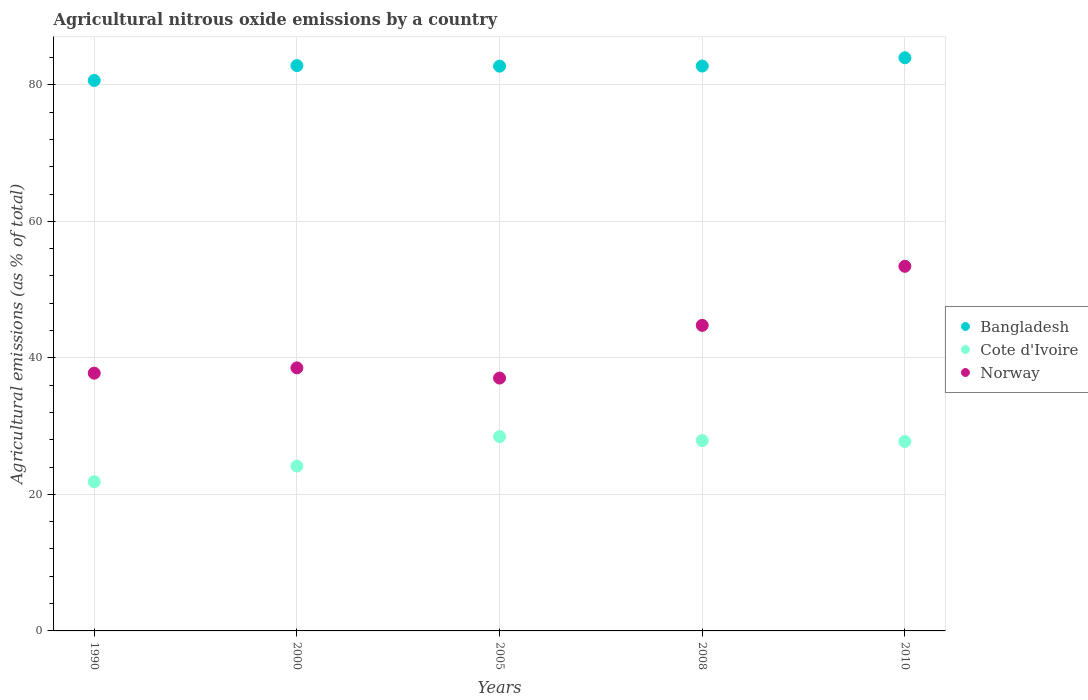How many different coloured dotlines are there?
Make the answer very short. 3. What is the amount of agricultural nitrous oxide emitted in Norway in 2005?
Offer a terse response. 37.04. Across all years, what is the maximum amount of agricultural nitrous oxide emitted in Cote d'Ivoire?
Your answer should be very brief. 28.46. Across all years, what is the minimum amount of agricultural nitrous oxide emitted in Cote d'Ivoire?
Offer a very short reply. 21.85. What is the total amount of agricultural nitrous oxide emitted in Cote d'Ivoire in the graph?
Ensure brevity in your answer.  130.09. What is the difference between the amount of agricultural nitrous oxide emitted in Cote d'Ivoire in 2005 and that in 2008?
Your answer should be compact. 0.58. What is the difference between the amount of agricultural nitrous oxide emitted in Bangladesh in 2000 and the amount of agricultural nitrous oxide emitted in Cote d'Ivoire in 1990?
Keep it short and to the point. 60.95. What is the average amount of agricultural nitrous oxide emitted in Norway per year?
Your response must be concise. 42.3. In the year 1990, what is the difference between the amount of agricultural nitrous oxide emitted in Norway and amount of agricultural nitrous oxide emitted in Cote d'Ivoire?
Your answer should be very brief. 15.9. In how many years, is the amount of agricultural nitrous oxide emitted in Bangladesh greater than 56 %?
Give a very brief answer. 5. What is the ratio of the amount of agricultural nitrous oxide emitted in Bangladesh in 2005 to that in 2010?
Provide a succinct answer. 0.99. Is the amount of agricultural nitrous oxide emitted in Norway in 2000 less than that in 2005?
Offer a very short reply. No. What is the difference between the highest and the second highest amount of agricultural nitrous oxide emitted in Cote d'Ivoire?
Offer a very short reply. 0.58. What is the difference between the highest and the lowest amount of agricultural nitrous oxide emitted in Cote d'Ivoire?
Provide a short and direct response. 6.61. In how many years, is the amount of agricultural nitrous oxide emitted in Cote d'Ivoire greater than the average amount of agricultural nitrous oxide emitted in Cote d'Ivoire taken over all years?
Your response must be concise. 3. Is it the case that in every year, the sum of the amount of agricultural nitrous oxide emitted in Bangladesh and amount of agricultural nitrous oxide emitted in Cote d'Ivoire  is greater than the amount of agricultural nitrous oxide emitted in Norway?
Make the answer very short. Yes. Does the amount of agricultural nitrous oxide emitted in Bangladesh monotonically increase over the years?
Provide a short and direct response. No. Is the amount of agricultural nitrous oxide emitted in Cote d'Ivoire strictly greater than the amount of agricultural nitrous oxide emitted in Norway over the years?
Offer a very short reply. No. How many years are there in the graph?
Offer a very short reply. 5. Are the values on the major ticks of Y-axis written in scientific E-notation?
Offer a terse response. No. Does the graph contain any zero values?
Provide a succinct answer. No. How are the legend labels stacked?
Offer a terse response. Vertical. What is the title of the graph?
Make the answer very short. Agricultural nitrous oxide emissions by a country. What is the label or title of the X-axis?
Ensure brevity in your answer.  Years. What is the label or title of the Y-axis?
Keep it short and to the point. Agricultural emissions (as % of total). What is the Agricultural emissions (as % of total) of Bangladesh in 1990?
Ensure brevity in your answer.  80.63. What is the Agricultural emissions (as % of total) of Cote d'Ivoire in 1990?
Make the answer very short. 21.85. What is the Agricultural emissions (as % of total) of Norway in 1990?
Your answer should be very brief. 37.76. What is the Agricultural emissions (as % of total) in Bangladesh in 2000?
Offer a terse response. 82.81. What is the Agricultural emissions (as % of total) of Cote d'Ivoire in 2000?
Your answer should be compact. 24.15. What is the Agricultural emissions (as % of total) of Norway in 2000?
Give a very brief answer. 38.53. What is the Agricultural emissions (as % of total) of Bangladesh in 2005?
Your answer should be very brief. 82.73. What is the Agricultural emissions (as % of total) of Cote d'Ivoire in 2005?
Your answer should be compact. 28.46. What is the Agricultural emissions (as % of total) of Norway in 2005?
Provide a short and direct response. 37.04. What is the Agricultural emissions (as % of total) of Bangladesh in 2008?
Make the answer very short. 82.75. What is the Agricultural emissions (as % of total) of Cote d'Ivoire in 2008?
Provide a short and direct response. 27.88. What is the Agricultural emissions (as % of total) in Norway in 2008?
Ensure brevity in your answer.  44.76. What is the Agricultural emissions (as % of total) in Bangladesh in 2010?
Offer a terse response. 83.96. What is the Agricultural emissions (as % of total) of Cote d'Ivoire in 2010?
Offer a very short reply. 27.74. What is the Agricultural emissions (as % of total) in Norway in 2010?
Give a very brief answer. 53.41. Across all years, what is the maximum Agricultural emissions (as % of total) of Bangladesh?
Your response must be concise. 83.96. Across all years, what is the maximum Agricultural emissions (as % of total) of Cote d'Ivoire?
Ensure brevity in your answer.  28.46. Across all years, what is the maximum Agricultural emissions (as % of total) in Norway?
Your answer should be compact. 53.41. Across all years, what is the minimum Agricultural emissions (as % of total) in Bangladesh?
Your answer should be very brief. 80.63. Across all years, what is the minimum Agricultural emissions (as % of total) of Cote d'Ivoire?
Provide a short and direct response. 21.85. Across all years, what is the minimum Agricultural emissions (as % of total) of Norway?
Ensure brevity in your answer.  37.04. What is the total Agricultural emissions (as % of total) of Bangladesh in the graph?
Your answer should be very brief. 412.87. What is the total Agricultural emissions (as % of total) of Cote d'Ivoire in the graph?
Provide a succinct answer. 130.09. What is the total Agricultural emissions (as % of total) in Norway in the graph?
Offer a very short reply. 211.49. What is the difference between the Agricultural emissions (as % of total) in Bangladesh in 1990 and that in 2000?
Provide a succinct answer. -2.18. What is the difference between the Agricultural emissions (as % of total) of Cote d'Ivoire in 1990 and that in 2000?
Give a very brief answer. -2.29. What is the difference between the Agricultural emissions (as % of total) of Norway in 1990 and that in 2000?
Offer a very short reply. -0.78. What is the difference between the Agricultural emissions (as % of total) of Bangladesh in 1990 and that in 2005?
Ensure brevity in your answer.  -2.1. What is the difference between the Agricultural emissions (as % of total) of Cote d'Ivoire in 1990 and that in 2005?
Ensure brevity in your answer.  -6.61. What is the difference between the Agricultural emissions (as % of total) in Norway in 1990 and that in 2005?
Keep it short and to the point. 0.72. What is the difference between the Agricultural emissions (as % of total) in Bangladesh in 1990 and that in 2008?
Make the answer very short. -2.11. What is the difference between the Agricultural emissions (as % of total) of Cote d'Ivoire in 1990 and that in 2008?
Offer a terse response. -6.03. What is the difference between the Agricultural emissions (as % of total) of Norway in 1990 and that in 2008?
Make the answer very short. -7. What is the difference between the Agricultural emissions (as % of total) in Bangladesh in 1990 and that in 2010?
Offer a terse response. -3.32. What is the difference between the Agricultural emissions (as % of total) of Cote d'Ivoire in 1990 and that in 2010?
Make the answer very short. -5.89. What is the difference between the Agricultural emissions (as % of total) of Norway in 1990 and that in 2010?
Keep it short and to the point. -15.65. What is the difference between the Agricultural emissions (as % of total) of Bangladesh in 2000 and that in 2005?
Make the answer very short. 0.08. What is the difference between the Agricultural emissions (as % of total) of Cote d'Ivoire in 2000 and that in 2005?
Make the answer very short. -4.31. What is the difference between the Agricultural emissions (as % of total) in Norway in 2000 and that in 2005?
Provide a short and direct response. 1.49. What is the difference between the Agricultural emissions (as % of total) of Bangladesh in 2000 and that in 2008?
Ensure brevity in your answer.  0.06. What is the difference between the Agricultural emissions (as % of total) in Cote d'Ivoire in 2000 and that in 2008?
Make the answer very short. -3.73. What is the difference between the Agricultural emissions (as % of total) of Norway in 2000 and that in 2008?
Your answer should be compact. -6.23. What is the difference between the Agricultural emissions (as % of total) of Bangladesh in 2000 and that in 2010?
Your answer should be compact. -1.15. What is the difference between the Agricultural emissions (as % of total) in Cote d'Ivoire in 2000 and that in 2010?
Your answer should be compact. -3.6. What is the difference between the Agricultural emissions (as % of total) in Norway in 2000 and that in 2010?
Your answer should be very brief. -14.88. What is the difference between the Agricultural emissions (as % of total) of Bangladesh in 2005 and that in 2008?
Your response must be concise. -0.02. What is the difference between the Agricultural emissions (as % of total) of Cote d'Ivoire in 2005 and that in 2008?
Your response must be concise. 0.58. What is the difference between the Agricultural emissions (as % of total) in Norway in 2005 and that in 2008?
Provide a short and direct response. -7.72. What is the difference between the Agricultural emissions (as % of total) in Bangladesh in 2005 and that in 2010?
Provide a succinct answer. -1.23. What is the difference between the Agricultural emissions (as % of total) in Cote d'Ivoire in 2005 and that in 2010?
Keep it short and to the point. 0.72. What is the difference between the Agricultural emissions (as % of total) in Norway in 2005 and that in 2010?
Provide a succinct answer. -16.37. What is the difference between the Agricultural emissions (as % of total) of Bangladesh in 2008 and that in 2010?
Offer a very short reply. -1.21. What is the difference between the Agricultural emissions (as % of total) of Cote d'Ivoire in 2008 and that in 2010?
Your answer should be very brief. 0.14. What is the difference between the Agricultural emissions (as % of total) of Norway in 2008 and that in 2010?
Ensure brevity in your answer.  -8.65. What is the difference between the Agricultural emissions (as % of total) in Bangladesh in 1990 and the Agricultural emissions (as % of total) in Cote d'Ivoire in 2000?
Give a very brief answer. 56.49. What is the difference between the Agricultural emissions (as % of total) of Bangladesh in 1990 and the Agricultural emissions (as % of total) of Norway in 2000?
Keep it short and to the point. 42.1. What is the difference between the Agricultural emissions (as % of total) in Cote d'Ivoire in 1990 and the Agricultural emissions (as % of total) in Norway in 2000?
Your response must be concise. -16.68. What is the difference between the Agricultural emissions (as % of total) of Bangladesh in 1990 and the Agricultural emissions (as % of total) of Cote d'Ivoire in 2005?
Provide a short and direct response. 52.17. What is the difference between the Agricultural emissions (as % of total) of Bangladesh in 1990 and the Agricultural emissions (as % of total) of Norway in 2005?
Your answer should be very brief. 43.59. What is the difference between the Agricultural emissions (as % of total) in Cote d'Ivoire in 1990 and the Agricultural emissions (as % of total) in Norway in 2005?
Offer a terse response. -15.18. What is the difference between the Agricultural emissions (as % of total) in Bangladesh in 1990 and the Agricultural emissions (as % of total) in Cote d'Ivoire in 2008?
Make the answer very short. 52.75. What is the difference between the Agricultural emissions (as % of total) of Bangladesh in 1990 and the Agricultural emissions (as % of total) of Norway in 2008?
Ensure brevity in your answer.  35.87. What is the difference between the Agricultural emissions (as % of total) of Cote d'Ivoire in 1990 and the Agricultural emissions (as % of total) of Norway in 2008?
Provide a short and direct response. -22.9. What is the difference between the Agricultural emissions (as % of total) of Bangladesh in 1990 and the Agricultural emissions (as % of total) of Cote d'Ivoire in 2010?
Offer a terse response. 52.89. What is the difference between the Agricultural emissions (as % of total) in Bangladesh in 1990 and the Agricultural emissions (as % of total) in Norway in 2010?
Your response must be concise. 27.22. What is the difference between the Agricultural emissions (as % of total) of Cote d'Ivoire in 1990 and the Agricultural emissions (as % of total) of Norway in 2010?
Your answer should be very brief. -31.56. What is the difference between the Agricultural emissions (as % of total) in Bangladesh in 2000 and the Agricultural emissions (as % of total) in Cote d'Ivoire in 2005?
Provide a succinct answer. 54.35. What is the difference between the Agricultural emissions (as % of total) in Bangladesh in 2000 and the Agricultural emissions (as % of total) in Norway in 2005?
Your response must be concise. 45.77. What is the difference between the Agricultural emissions (as % of total) in Cote d'Ivoire in 2000 and the Agricultural emissions (as % of total) in Norway in 2005?
Provide a succinct answer. -12.89. What is the difference between the Agricultural emissions (as % of total) of Bangladesh in 2000 and the Agricultural emissions (as % of total) of Cote d'Ivoire in 2008?
Your answer should be compact. 54.93. What is the difference between the Agricultural emissions (as % of total) of Bangladesh in 2000 and the Agricultural emissions (as % of total) of Norway in 2008?
Provide a short and direct response. 38.05. What is the difference between the Agricultural emissions (as % of total) in Cote d'Ivoire in 2000 and the Agricultural emissions (as % of total) in Norway in 2008?
Ensure brevity in your answer.  -20.61. What is the difference between the Agricultural emissions (as % of total) in Bangladesh in 2000 and the Agricultural emissions (as % of total) in Cote d'Ivoire in 2010?
Keep it short and to the point. 55.07. What is the difference between the Agricultural emissions (as % of total) of Bangladesh in 2000 and the Agricultural emissions (as % of total) of Norway in 2010?
Ensure brevity in your answer.  29.4. What is the difference between the Agricultural emissions (as % of total) of Cote d'Ivoire in 2000 and the Agricultural emissions (as % of total) of Norway in 2010?
Your response must be concise. -29.26. What is the difference between the Agricultural emissions (as % of total) in Bangladesh in 2005 and the Agricultural emissions (as % of total) in Cote d'Ivoire in 2008?
Your response must be concise. 54.85. What is the difference between the Agricultural emissions (as % of total) in Bangladesh in 2005 and the Agricultural emissions (as % of total) in Norway in 2008?
Make the answer very short. 37.97. What is the difference between the Agricultural emissions (as % of total) of Cote d'Ivoire in 2005 and the Agricultural emissions (as % of total) of Norway in 2008?
Your answer should be compact. -16.3. What is the difference between the Agricultural emissions (as % of total) in Bangladesh in 2005 and the Agricultural emissions (as % of total) in Cote d'Ivoire in 2010?
Ensure brevity in your answer.  54.99. What is the difference between the Agricultural emissions (as % of total) in Bangladesh in 2005 and the Agricultural emissions (as % of total) in Norway in 2010?
Offer a terse response. 29.32. What is the difference between the Agricultural emissions (as % of total) of Cote d'Ivoire in 2005 and the Agricultural emissions (as % of total) of Norway in 2010?
Your response must be concise. -24.95. What is the difference between the Agricultural emissions (as % of total) in Bangladesh in 2008 and the Agricultural emissions (as % of total) in Cote d'Ivoire in 2010?
Offer a terse response. 55. What is the difference between the Agricultural emissions (as % of total) of Bangladesh in 2008 and the Agricultural emissions (as % of total) of Norway in 2010?
Keep it short and to the point. 29.34. What is the difference between the Agricultural emissions (as % of total) of Cote d'Ivoire in 2008 and the Agricultural emissions (as % of total) of Norway in 2010?
Your response must be concise. -25.53. What is the average Agricultural emissions (as % of total) in Bangladesh per year?
Offer a very short reply. 82.57. What is the average Agricultural emissions (as % of total) of Cote d'Ivoire per year?
Provide a short and direct response. 26.02. What is the average Agricultural emissions (as % of total) of Norway per year?
Keep it short and to the point. 42.3. In the year 1990, what is the difference between the Agricultural emissions (as % of total) of Bangladesh and Agricultural emissions (as % of total) of Cote d'Ivoire?
Provide a succinct answer. 58.78. In the year 1990, what is the difference between the Agricultural emissions (as % of total) in Bangladesh and Agricultural emissions (as % of total) in Norway?
Offer a terse response. 42.88. In the year 1990, what is the difference between the Agricultural emissions (as % of total) of Cote d'Ivoire and Agricultural emissions (as % of total) of Norway?
Give a very brief answer. -15.9. In the year 2000, what is the difference between the Agricultural emissions (as % of total) in Bangladesh and Agricultural emissions (as % of total) in Cote d'Ivoire?
Make the answer very short. 58.66. In the year 2000, what is the difference between the Agricultural emissions (as % of total) in Bangladesh and Agricultural emissions (as % of total) in Norway?
Offer a terse response. 44.28. In the year 2000, what is the difference between the Agricultural emissions (as % of total) in Cote d'Ivoire and Agricultural emissions (as % of total) in Norway?
Provide a short and direct response. -14.38. In the year 2005, what is the difference between the Agricultural emissions (as % of total) in Bangladesh and Agricultural emissions (as % of total) in Cote d'Ivoire?
Ensure brevity in your answer.  54.27. In the year 2005, what is the difference between the Agricultural emissions (as % of total) in Bangladesh and Agricultural emissions (as % of total) in Norway?
Offer a very short reply. 45.69. In the year 2005, what is the difference between the Agricultural emissions (as % of total) of Cote d'Ivoire and Agricultural emissions (as % of total) of Norway?
Your answer should be very brief. -8.58. In the year 2008, what is the difference between the Agricultural emissions (as % of total) in Bangladesh and Agricultural emissions (as % of total) in Cote d'Ivoire?
Keep it short and to the point. 54.87. In the year 2008, what is the difference between the Agricultural emissions (as % of total) of Bangladesh and Agricultural emissions (as % of total) of Norway?
Keep it short and to the point. 37.99. In the year 2008, what is the difference between the Agricultural emissions (as % of total) in Cote d'Ivoire and Agricultural emissions (as % of total) in Norway?
Ensure brevity in your answer.  -16.88. In the year 2010, what is the difference between the Agricultural emissions (as % of total) of Bangladesh and Agricultural emissions (as % of total) of Cote d'Ivoire?
Make the answer very short. 56.21. In the year 2010, what is the difference between the Agricultural emissions (as % of total) in Bangladesh and Agricultural emissions (as % of total) in Norway?
Your response must be concise. 30.55. In the year 2010, what is the difference between the Agricultural emissions (as % of total) of Cote d'Ivoire and Agricultural emissions (as % of total) of Norway?
Your answer should be very brief. -25.67. What is the ratio of the Agricultural emissions (as % of total) in Bangladesh in 1990 to that in 2000?
Provide a short and direct response. 0.97. What is the ratio of the Agricultural emissions (as % of total) in Cote d'Ivoire in 1990 to that in 2000?
Your response must be concise. 0.91. What is the ratio of the Agricultural emissions (as % of total) of Norway in 1990 to that in 2000?
Ensure brevity in your answer.  0.98. What is the ratio of the Agricultural emissions (as % of total) in Bangladesh in 1990 to that in 2005?
Your answer should be very brief. 0.97. What is the ratio of the Agricultural emissions (as % of total) of Cote d'Ivoire in 1990 to that in 2005?
Keep it short and to the point. 0.77. What is the ratio of the Agricultural emissions (as % of total) of Norway in 1990 to that in 2005?
Make the answer very short. 1.02. What is the ratio of the Agricultural emissions (as % of total) in Bangladesh in 1990 to that in 2008?
Your response must be concise. 0.97. What is the ratio of the Agricultural emissions (as % of total) in Cote d'Ivoire in 1990 to that in 2008?
Give a very brief answer. 0.78. What is the ratio of the Agricultural emissions (as % of total) in Norway in 1990 to that in 2008?
Your answer should be very brief. 0.84. What is the ratio of the Agricultural emissions (as % of total) in Bangladesh in 1990 to that in 2010?
Offer a terse response. 0.96. What is the ratio of the Agricultural emissions (as % of total) in Cote d'Ivoire in 1990 to that in 2010?
Your answer should be very brief. 0.79. What is the ratio of the Agricultural emissions (as % of total) in Norway in 1990 to that in 2010?
Keep it short and to the point. 0.71. What is the ratio of the Agricultural emissions (as % of total) of Bangladesh in 2000 to that in 2005?
Offer a terse response. 1. What is the ratio of the Agricultural emissions (as % of total) of Cote d'Ivoire in 2000 to that in 2005?
Offer a very short reply. 0.85. What is the ratio of the Agricultural emissions (as % of total) of Norway in 2000 to that in 2005?
Provide a succinct answer. 1.04. What is the ratio of the Agricultural emissions (as % of total) in Cote d'Ivoire in 2000 to that in 2008?
Ensure brevity in your answer.  0.87. What is the ratio of the Agricultural emissions (as % of total) in Norway in 2000 to that in 2008?
Your response must be concise. 0.86. What is the ratio of the Agricultural emissions (as % of total) in Bangladesh in 2000 to that in 2010?
Give a very brief answer. 0.99. What is the ratio of the Agricultural emissions (as % of total) in Cote d'Ivoire in 2000 to that in 2010?
Your response must be concise. 0.87. What is the ratio of the Agricultural emissions (as % of total) of Norway in 2000 to that in 2010?
Offer a terse response. 0.72. What is the ratio of the Agricultural emissions (as % of total) of Cote d'Ivoire in 2005 to that in 2008?
Give a very brief answer. 1.02. What is the ratio of the Agricultural emissions (as % of total) of Norway in 2005 to that in 2008?
Keep it short and to the point. 0.83. What is the ratio of the Agricultural emissions (as % of total) in Bangladesh in 2005 to that in 2010?
Provide a short and direct response. 0.99. What is the ratio of the Agricultural emissions (as % of total) of Cote d'Ivoire in 2005 to that in 2010?
Give a very brief answer. 1.03. What is the ratio of the Agricultural emissions (as % of total) in Norway in 2005 to that in 2010?
Ensure brevity in your answer.  0.69. What is the ratio of the Agricultural emissions (as % of total) of Bangladesh in 2008 to that in 2010?
Offer a terse response. 0.99. What is the ratio of the Agricultural emissions (as % of total) in Norway in 2008 to that in 2010?
Offer a very short reply. 0.84. What is the difference between the highest and the second highest Agricultural emissions (as % of total) in Bangladesh?
Give a very brief answer. 1.15. What is the difference between the highest and the second highest Agricultural emissions (as % of total) in Cote d'Ivoire?
Offer a very short reply. 0.58. What is the difference between the highest and the second highest Agricultural emissions (as % of total) in Norway?
Ensure brevity in your answer.  8.65. What is the difference between the highest and the lowest Agricultural emissions (as % of total) of Bangladesh?
Provide a succinct answer. 3.32. What is the difference between the highest and the lowest Agricultural emissions (as % of total) of Cote d'Ivoire?
Your response must be concise. 6.61. What is the difference between the highest and the lowest Agricultural emissions (as % of total) of Norway?
Provide a short and direct response. 16.37. 